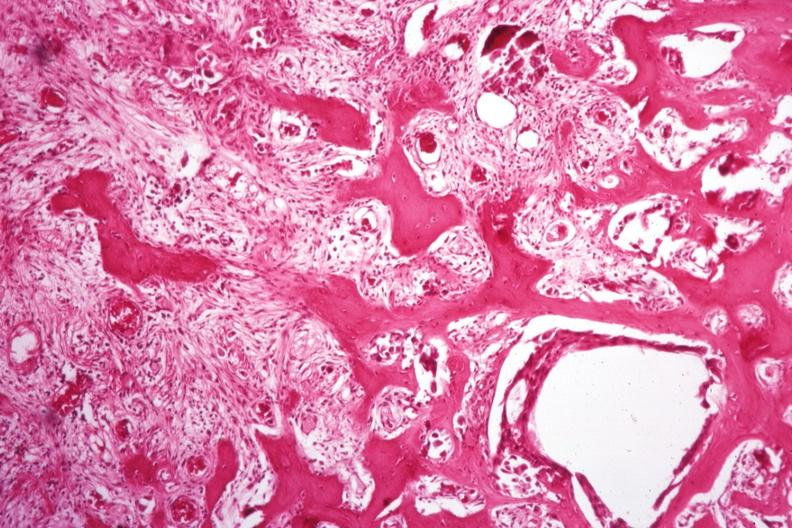what is present?
Answer the question using a single word or phrase. Joints 